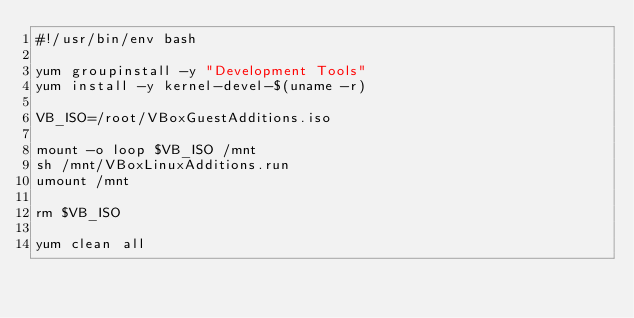Convert code to text. <code><loc_0><loc_0><loc_500><loc_500><_Bash_>#!/usr/bin/env bash

yum groupinstall -y "Development Tools"
yum install -y kernel-devel-$(uname -r)

VB_ISO=/root/VBoxGuestAdditions.iso

mount -o loop $VB_ISO /mnt
sh /mnt/VBoxLinuxAdditions.run
umount /mnt

rm $VB_ISO

yum clean all</code> 